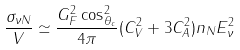<formula> <loc_0><loc_0><loc_500><loc_500>\frac { \sigma _ { \nu N } } { V } \simeq \frac { G _ { F } ^ { 2 } \cos _ { \theta _ { c } } ^ { 2 } } { 4 \pi } ( C _ { V } ^ { 2 } + 3 C _ { A } ^ { 2 } ) n _ { N } E _ { \nu } ^ { 2 }</formula> 